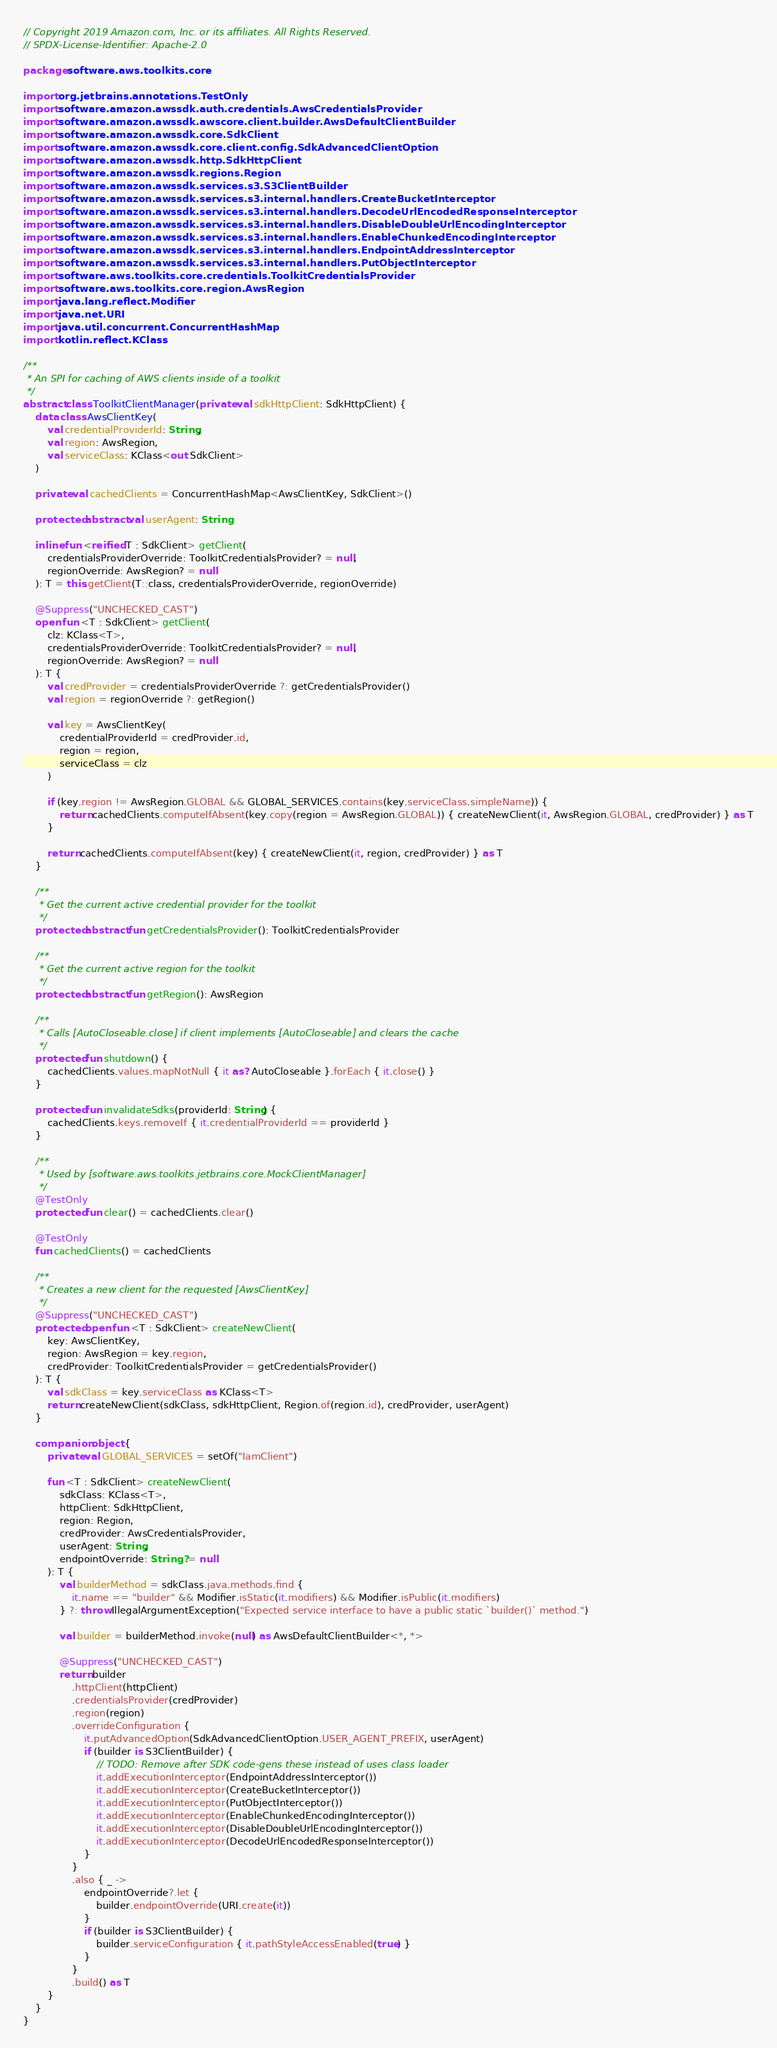Convert code to text. <code><loc_0><loc_0><loc_500><loc_500><_Kotlin_>// Copyright 2019 Amazon.com, Inc. or its affiliates. All Rights Reserved.
// SPDX-License-Identifier: Apache-2.0

package software.aws.toolkits.core

import org.jetbrains.annotations.TestOnly
import software.amazon.awssdk.auth.credentials.AwsCredentialsProvider
import software.amazon.awssdk.awscore.client.builder.AwsDefaultClientBuilder
import software.amazon.awssdk.core.SdkClient
import software.amazon.awssdk.core.client.config.SdkAdvancedClientOption
import software.amazon.awssdk.http.SdkHttpClient
import software.amazon.awssdk.regions.Region
import software.amazon.awssdk.services.s3.S3ClientBuilder
import software.amazon.awssdk.services.s3.internal.handlers.CreateBucketInterceptor
import software.amazon.awssdk.services.s3.internal.handlers.DecodeUrlEncodedResponseInterceptor
import software.amazon.awssdk.services.s3.internal.handlers.DisableDoubleUrlEncodingInterceptor
import software.amazon.awssdk.services.s3.internal.handlers.EnableChunkedEncodingInterceptor
import software.amazon.awssdk.services.s3.internal.handlers.EndpointAddressInterceptor
import software.amazon.awssdk.services.s3.internal.handlers.PutObjectInterceptor
import software.aws.toolkits.core.credentials.ToolkitCredentialsProvider
import software.aws.toolkits.core.region.AwsRegion
import java.lang.reflect.Modifier
import java.net.URI
import java.util.concurrent.ConcurrentHashMap
import kotlin.reflect.KClass

/**
 * An SPI for caching of AWS clients inside of a toolkit
 */
abstract class ToolkitClientManager(private val sdkHttpClient: SdkHttpClient) {
    data class AwsClientKey(
        val credentialProviderId: String,
        val region: AwsRegion,
        val serviceClass: KClass<out SdkClient>
    )

    private val cachedClients = ConcurrentHashMap<AwsClientKey, SdkClient>()

    protected abstract val userAgent: String

    inline fun <reified T : SdkClient> getClient(
        credentialsProviderOverride: ToolkitCredentialsProvider? = null,
        regionOverride: AwsRegion? = null
    ): T = this.getClient(T::class, credentialsProviderOverride, regionOverride)

    @Suppress("UNCHECKED_CAST")
    open fun <T : SdkClient> getClient(
        clz: KClass<T>,
        credentialsProviderOverride: ToolkitCredentialsProvider? = null,
        regionOverride: AwsRegion? = null
    ): T {
        val credProvider = credentialsProviderOverride ?: getCredentialsProvider()
        val region = regionOverride ?: getRegion()

        val key = AwsClientKey(
            credentialProviderId = credProvider.id,
            region = region,
            serviceClass = clz
        )

        if (key.region != AwsRegion.GLOBAL && GLOBAL_SERVICES.contains(key.serviceClass.simpleName)) {
            return cachedClients.computeIfAbsent(key.copy(region = AwsRegion.GLOBAL)) { createNewClient(it, AwsRegion.GLOBAL, credProvider) } as T
        }

        return cachedClients.computeIfAbsent(key) { createNewClient(it, region, credProvider) } as T
    }

    /**
     * Get the current active credential provider for the toolkit
     */
    protected abstract fun getCredentialsProvider(): ToolkitCredentialsProvider

    /**
     * Get the current active region for the toolkit
     */
    protected abstract fun getRegion(): AwsRegion

    /**
     * Calls [AutoCloseable.close] if client implements [AutoCloseable] and clears the cache
     */
    protected fun shutdown() {
        cachedClients.values.mapNotNull { it as? AutoCloseable }.forEach { it.close() }
    }

    protected fun invalidateSdks(providerId: String) {
        cachedClients.keys.removeIf { it.credentialProviderId == providerId }
    }

    /**
     * Used by [software.aws.toolkits.jetbrains.core.MockClientManager]
     */
    @TestOnly
    protected fun clear() = cachedClients.clear()

    @TestOnly
    fun cachedClients() = cachedClients

    /**
     * Creates a new client for the requested [AwsClientKey]
     */
    @Suppress("UNCHECKED_CAST")
    protected open fun <T : SdkClient> createNewClient(
        key: AwsClientKey,
        region: AwsRegion = key.region,
        credProvider: ToolkitCredentialsProvider = getCredentialsProvider()
    ): T {
        val sdkClass = key.serviceClass as KClass<T>
        return createNewClient(sdkClass, sdkHttpClient, Region.of(region.id), credProvider, userAgent)
    }

    companion object {
        private val GLOBAL_SERVICES = setOf("IamClient")

        fun <T : SdkClient> createNewClient(
            sdkClass: KClass<T>,
            httpClient: SdkHttpClient,
            region: Region,
            credProvider: AwsCredentialsProvider,
            userAgent: String,
            endpointOverride: String? = null
        ): T {
            val builderMethod = sdkClass.java.methods.find {
                it.name == "builder" && Modifier.isStatic(it.modifiers) && Modifier.isPublic(it.modifiers)
            } ?: throw IllegalArgumentException("Expected service interface to have a public static `builder()` method.")

            val builder = builderMethod.invoke(null) as AwsDefaultClientBuilder<*, *>

            @Suppress("UNCHECKED_CAST")
            return builder
                .httpClient(httpClient)
                .credentialsProvider(credProvider)
                .region(region)
                .overrideConfiguration {
                    it.putAdvancedOption(SdkAdvancedClientOption.USER_AGENT_PREFIX, userAgent)
                    if (builder is S3ClientBuilder) {
                        // TODO: Remove after SDK code-gens these instead of uses class loader
                        it.addExecutionInterceptor(EndpointAddressInterceptor())
                        it.addExecutionInterceptor(CreateBucketInterceptor())
                        it.addExecutionInterceptor(PutObjectInterceptor())
                        it.addExecutionInterceptor(EnableChunkedEncodingInterceptor())
                        it.addExecutionInterceptor(DisableDoubleUrlEncodingInterceptor())
                        it.addExecutionInterceptor(DecodeUrlEncodedResponseInterceptor())
                    }
                }
                .also { _ ->
                    endpointOverride?.let {
                        builder.endpointOverride(URI.create(it))
                    }
                    if (builder is S3ClientBuilder) {
                        builder.serviceConfiguration { it.pathStyleAccessEnabled(true) }
                    }
                }
                .build() as T
        }
    }
}
</code> 